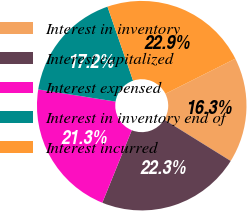<chart> <loc_0><loc_0><loc_500><loc_500><pie_chart><fcel>Interest in inventory<fcel>Interest capitalized<fcel>Interest expensed<fcel>Interest in inventory end of<fcel>Interest incurred<nl><fcel>16.26%<fcel>22.29%<fcel>21.34%<fcel>17.22%<fcel>22.89%<nl></chart> 